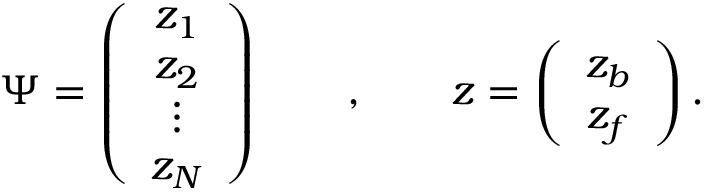Convert formula to latex. <formula><loc_0><loc_0><loc_500><loc_500>\Psi = \left ( \begin{array} { c } { { z _ { 1 } } } \\ { { z _ { 2 } } } \\ { \vdots } \\ { { z _ { N } } } \end{array} \right ) \quad , \quad z = \left ( \begin{array} { c } { { z _ { b } } } \\ { { z _ { f } } } \end{array} \right ) .</formula> 